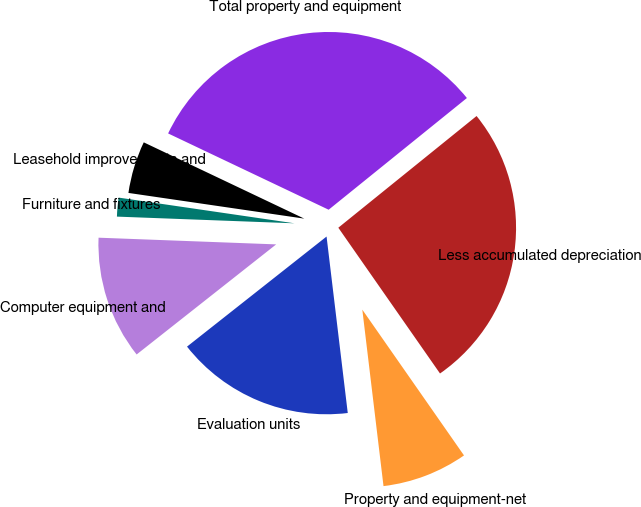<chart> <loc_0><loc_0><loc_500><loc_500><pie_chart><fcel>Evaluation units<fcel>Computer equipment and<fcel>Furniture and fixtures<fcel>Leasehold improvements and<fcel>Total property and equipment<fcel>Less accumulated depreciation<fcel>Property and equipment-net<nl><fcel>16.27%<fcel>11.23%<fcel>1.71%<fcel>4.75%<fcel>32.12%<fcel>26.12%<fcel>7.79%<nl></chart> 